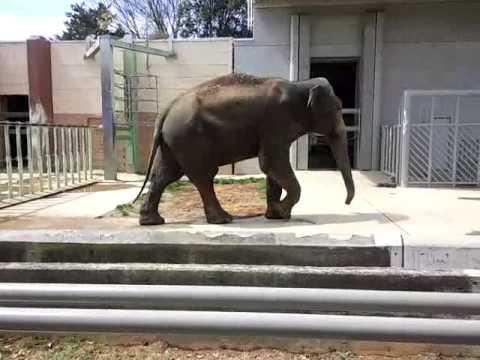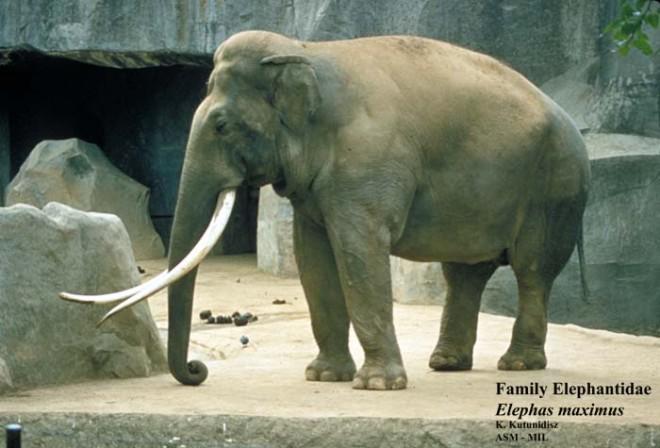The first image is the image on the left, the second image is the image on the right. Considering the images on both sides, is "Each picture has only one elephant in it." valid? Answer yes or no. Yes. The first image is the image on the left, the second image is the image on the right. Assess this claim about the two images: "An elephant is in profile facing the right.". Correct or not? Answer yes or no. Yes. 